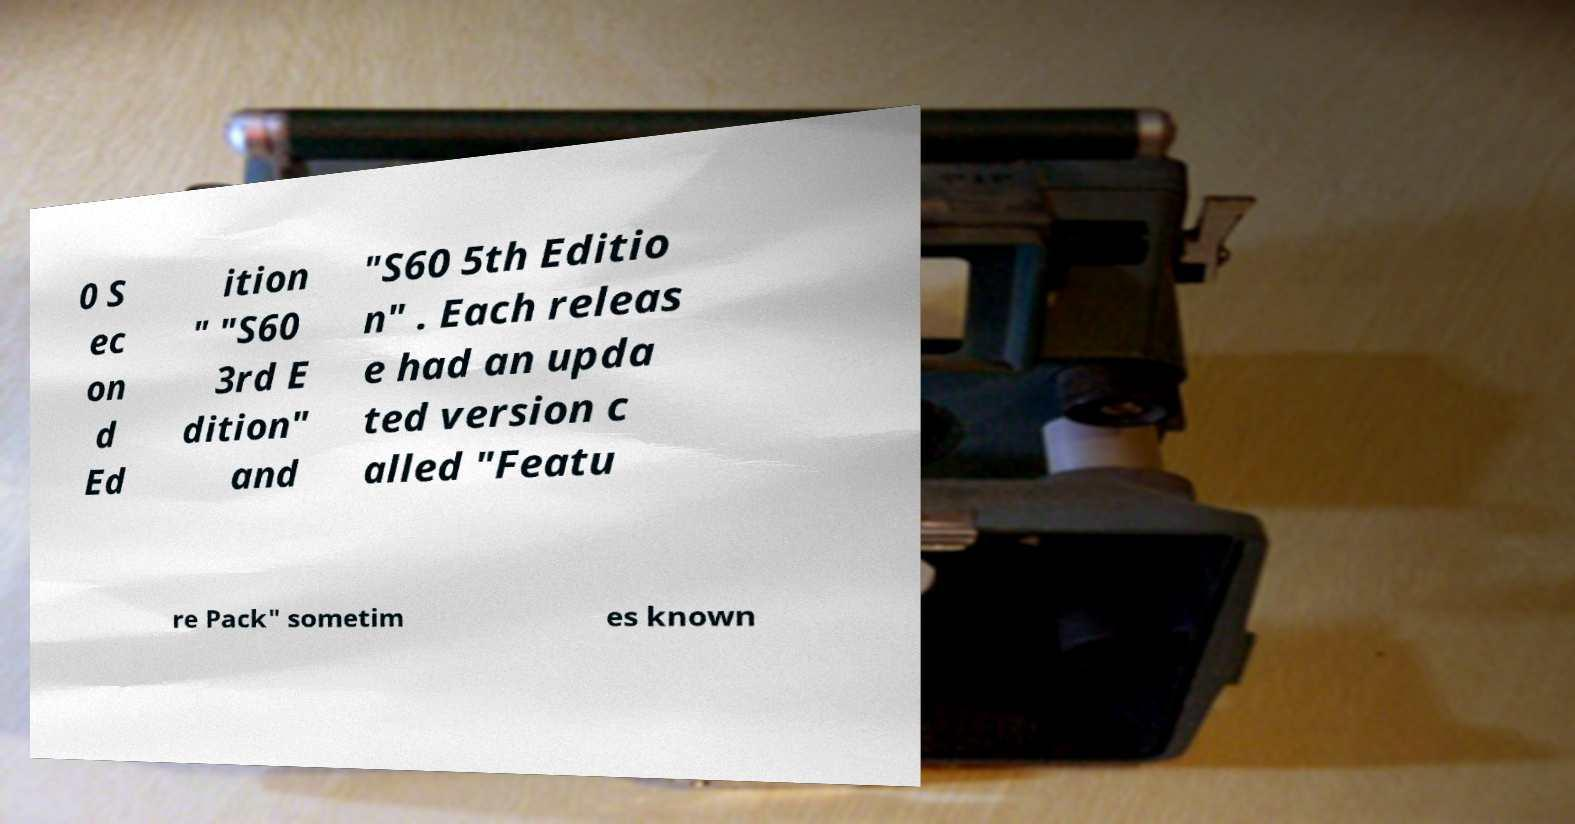Could you assist in decoding the text presented in this image and type it out clearly? 0 S ec on d Ed ition " "S60 3rd E dition" and "S60 5th Editio n" . Each releas e had an upda ted version c alled "Featu re Pack" sometim es known 